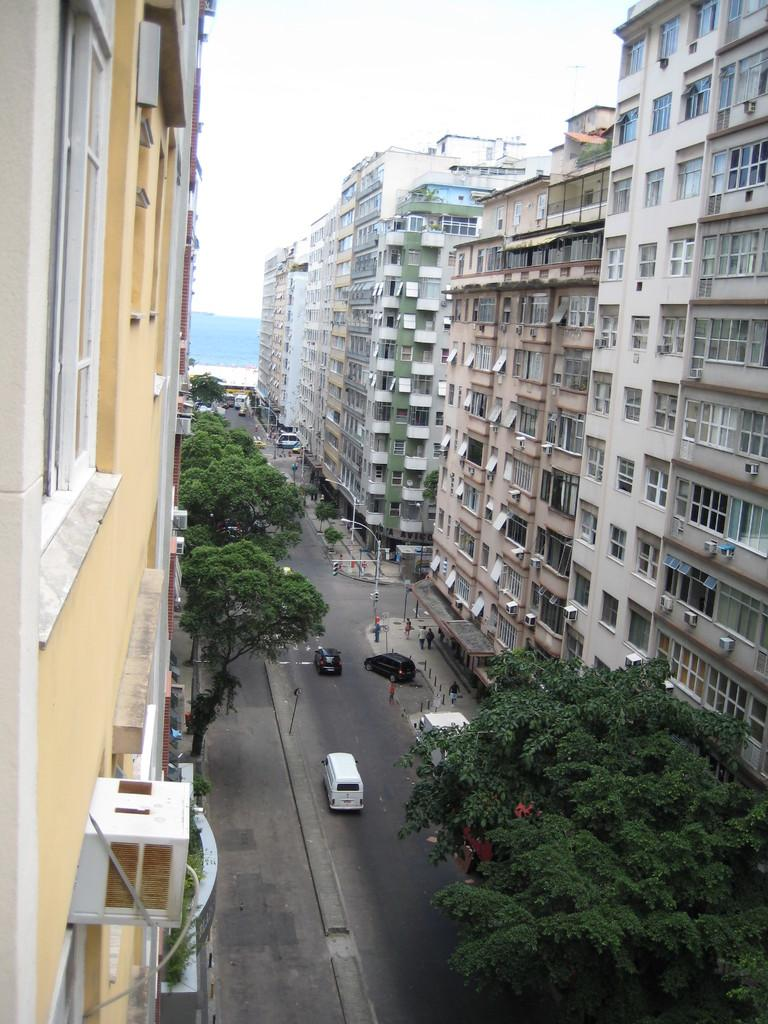What is the main feature of the image? There is a road in the image. What is happening on the road? Cars and people are present on the road. What can be seen on both sides of the image? There are buildings and trees on both sides of the image. What type of reaction can be seen from the bat in the image? There is no bat present in the image, so it is not possible to observe any reaction from a bat. 